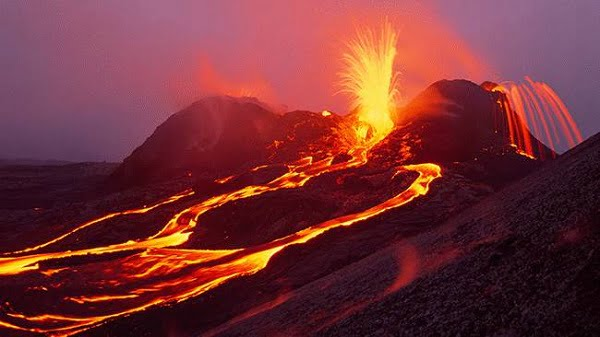What effects might this volcanic eruption have on the local environment? Volcanic eruptions like this one can have profound effects on the local environment. Initially, the lava flows destroy vegetation, and the ash fallout can impact air quality and water sources. Over time, however, these materials can enrich the soil with minerals, leading to fertile grounds that support new vegetative growth. Ecologically, eruptions can also create new habitats and alter existing ecosystems, sometimes introducing new species or displacing others. 